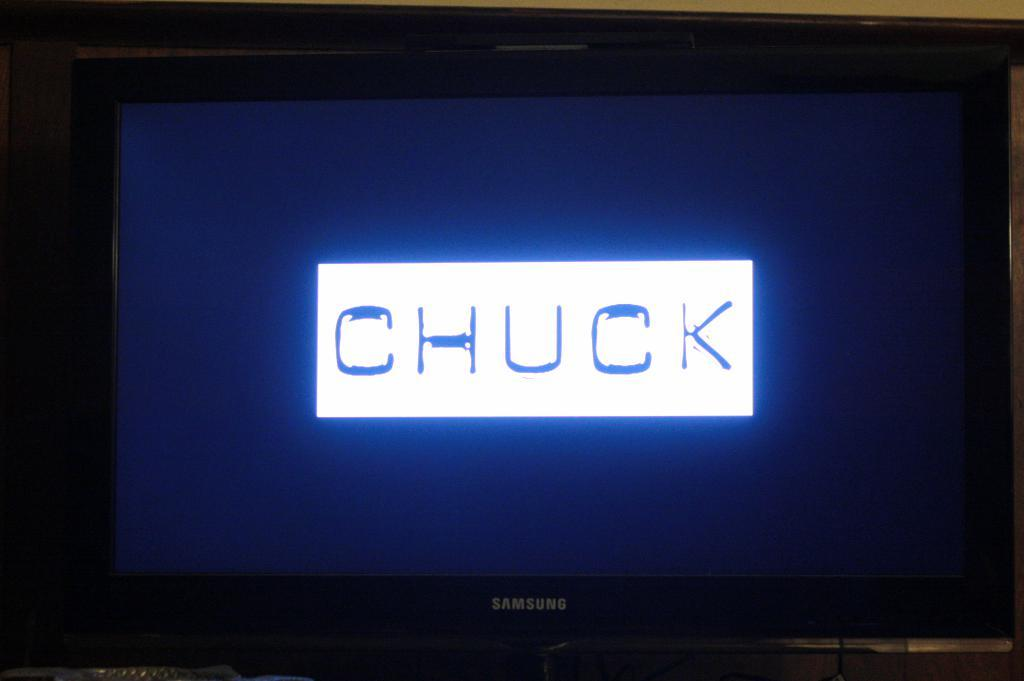Provide a one-sentence caption for the provided image. A Samsung TV is about to play a tv show called CHUCK. 